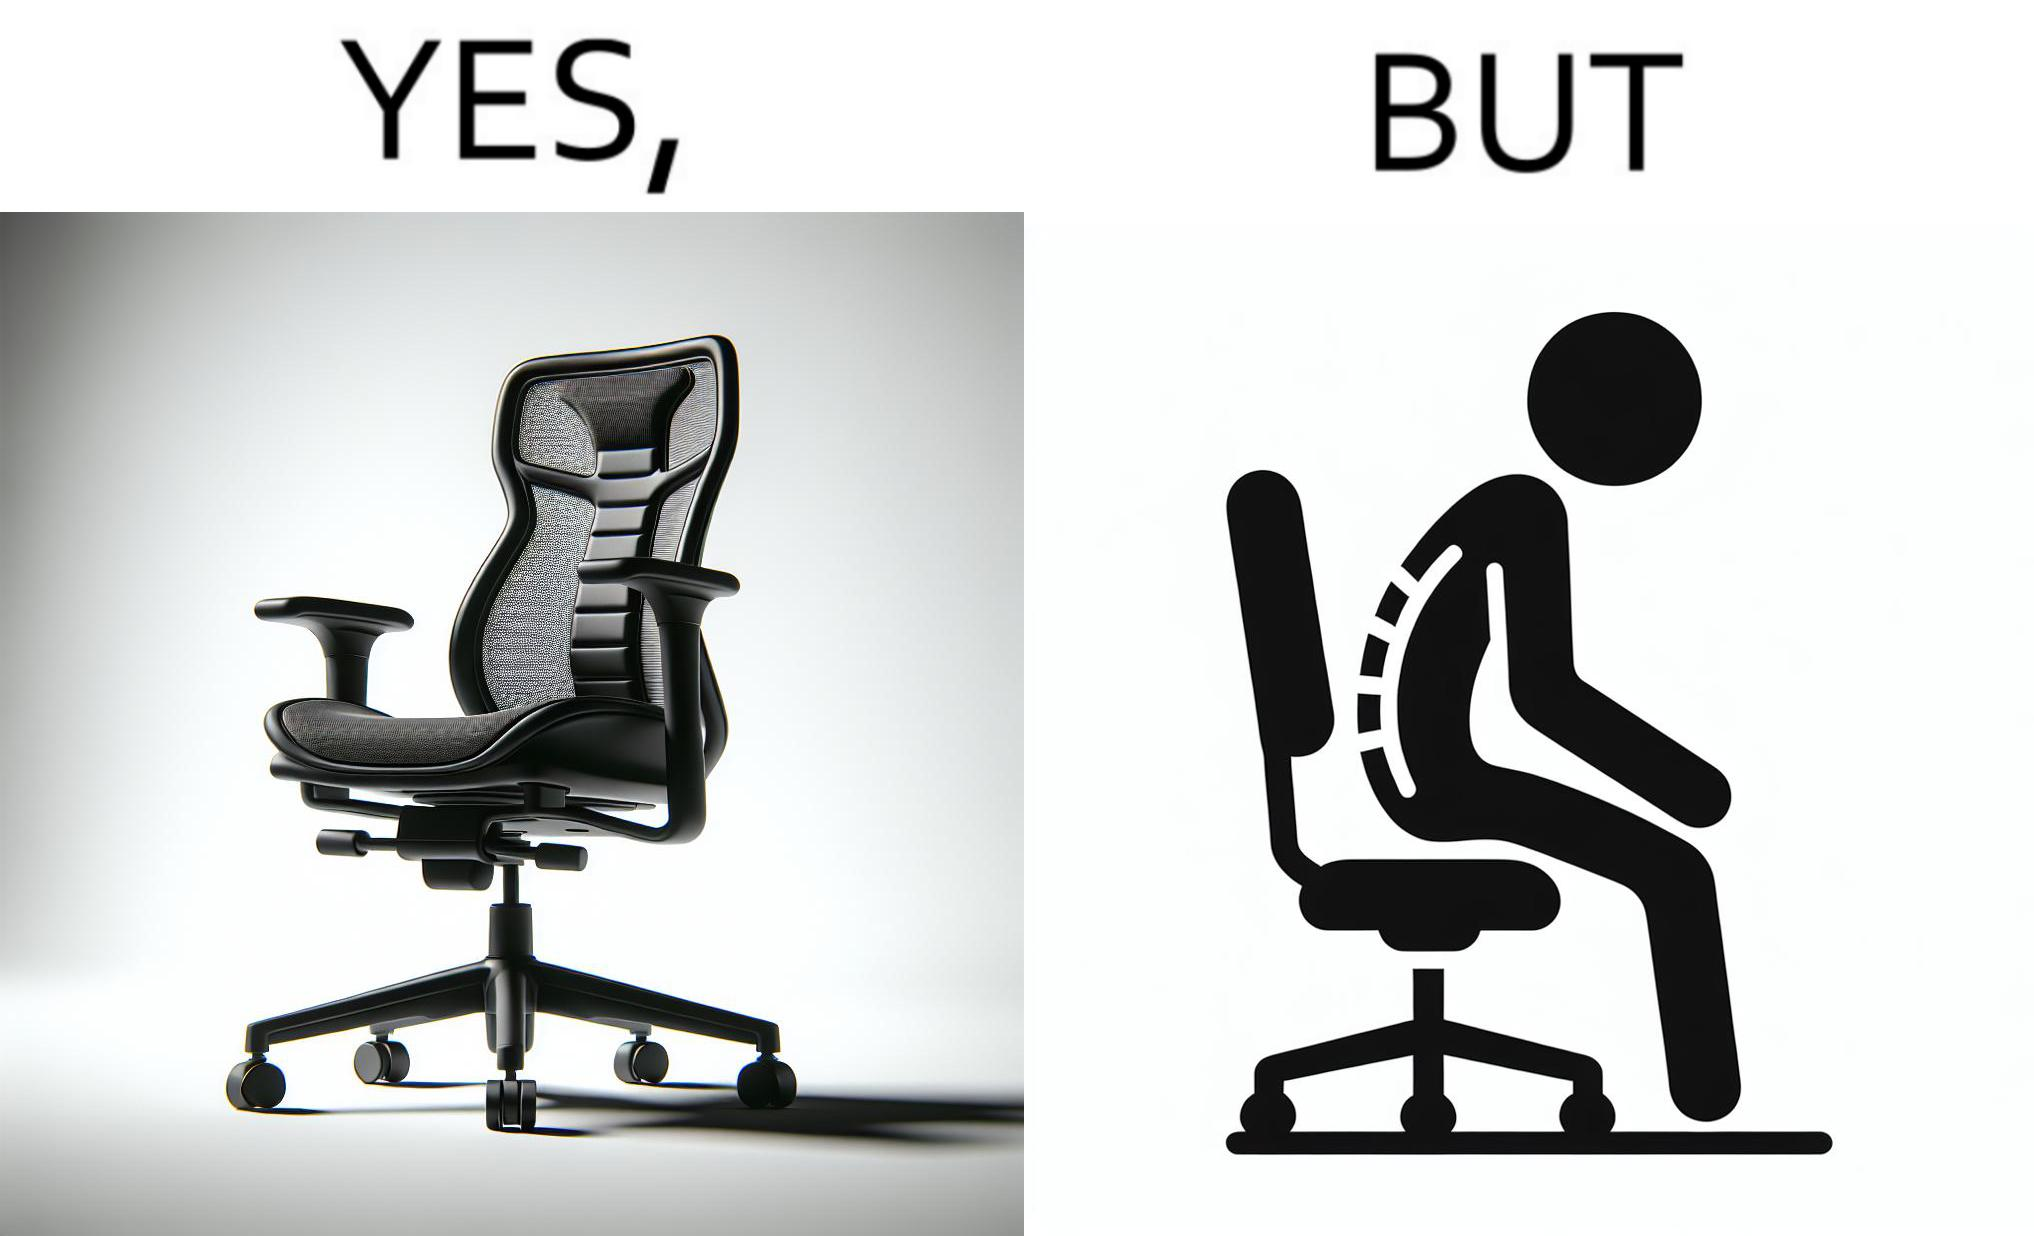Describe the satirical element in this image. The image is ironical, as even though the ergonomic chair is meant to facilitate an upright and comfortable posture for the person sitting on it, the person sitting on it still has a bent posture, as the person is not utilizing the backrest. 